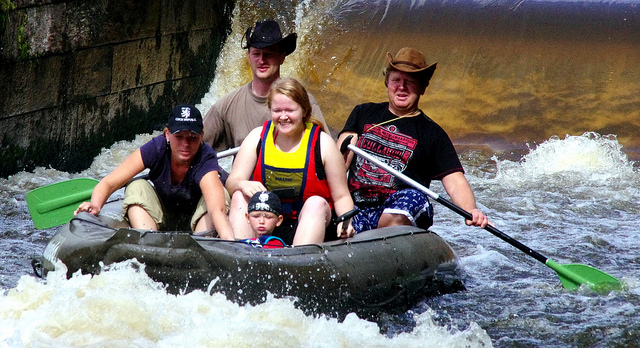What is this boat called?
A. raft
B. lifeboat
C. ship
D. inner tube
Answer with the option's letter from the given choices directly. The correct answer is A, a raft. This particular raft appears to be an inflatable boat, specifically designed for leisure activities such as white-water rafting. It's equipped with paddles and seems to be built for a group, making it ideal for navigating through the rough water in the image. 